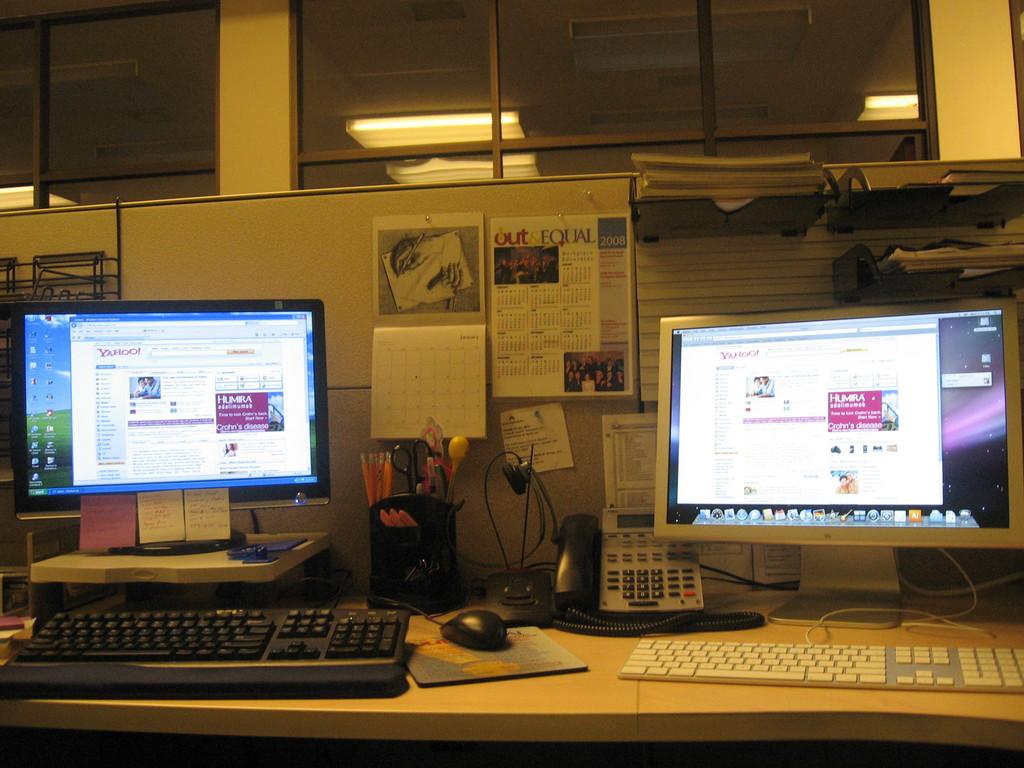What website are the screens on?
Give a very brief answer. Yahoo. 